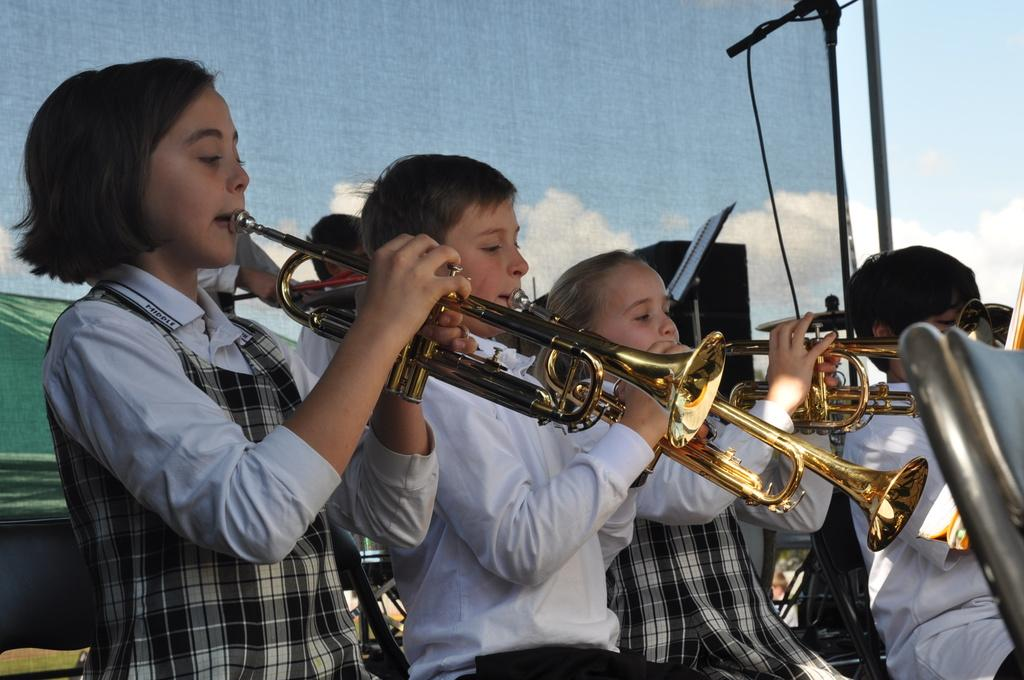What are the kids in the image doing? The kids in the image are playing trumpets. What is the purpose of the microphone placed on a stand? The microphone is likely used for amplifying the sound of the trumpets. What can be seen in the background of the image? There is a curtain and the sky visible in the background of the image. What is another object in the image that might be related to sound? There is a speaker in the image. Where is the jail located in the image? There is no jail present in the image. What type of waste can be seen in the image? There is no waste visible in the image. 